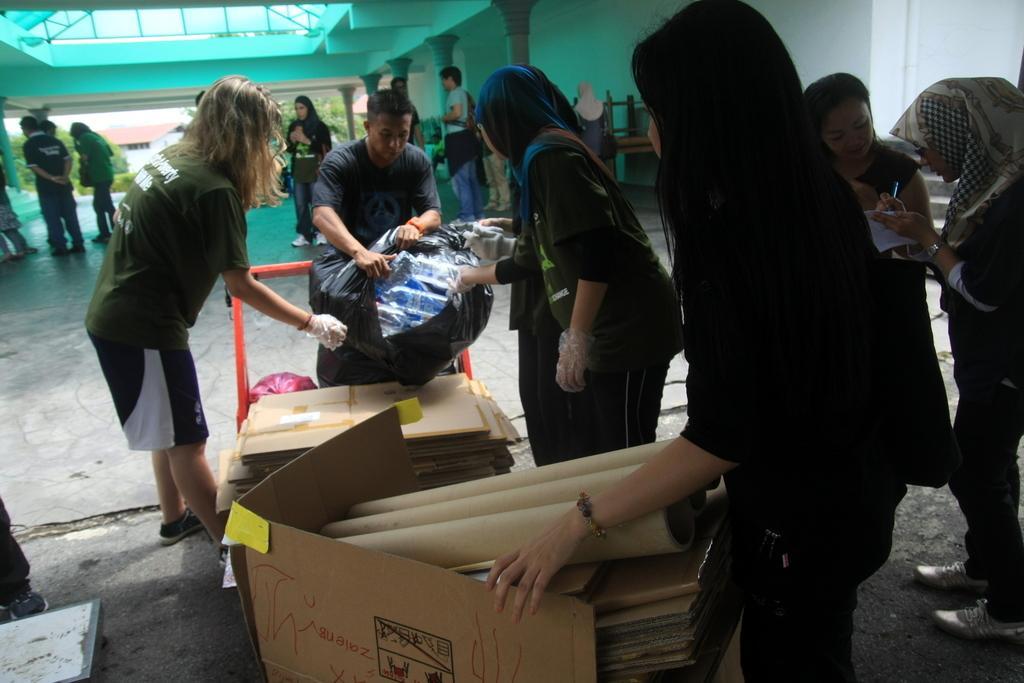Could you give a brief overview of what you see in this image? In this image I can see a group of people are standing on the floor, trolley, cover and carton boxes. In the background I can see a wall, pillars, trees and the sky. This image is taken may be in a hall. 